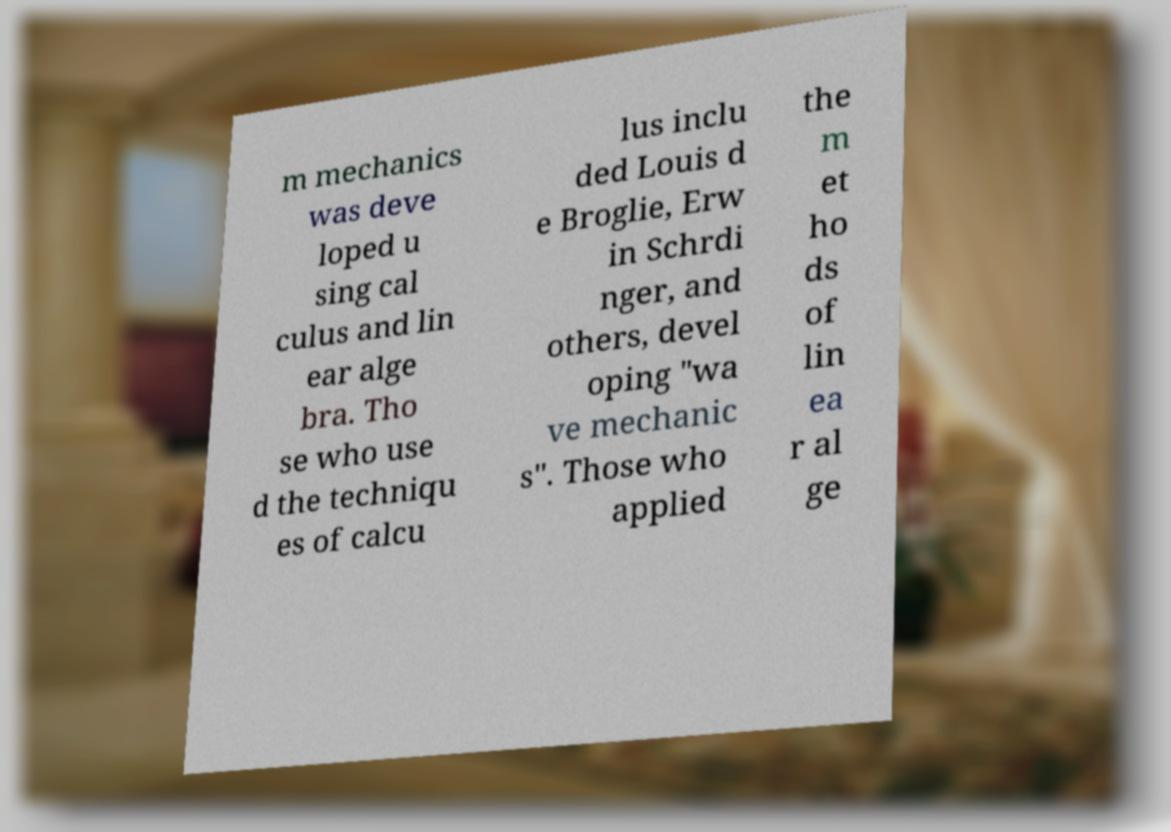Could you extract and type out the text from this image? m mechanics was deve loped u sing cal culus and lin ear alge bra. Tho se who use d the techniqu es of calcu lus inclu ded Louis d e Broglie, Erw in Schrdi nger, and others, devel oping "wa ve mechanic s". Those who applied the m et ho ds of lin ea r al ge 